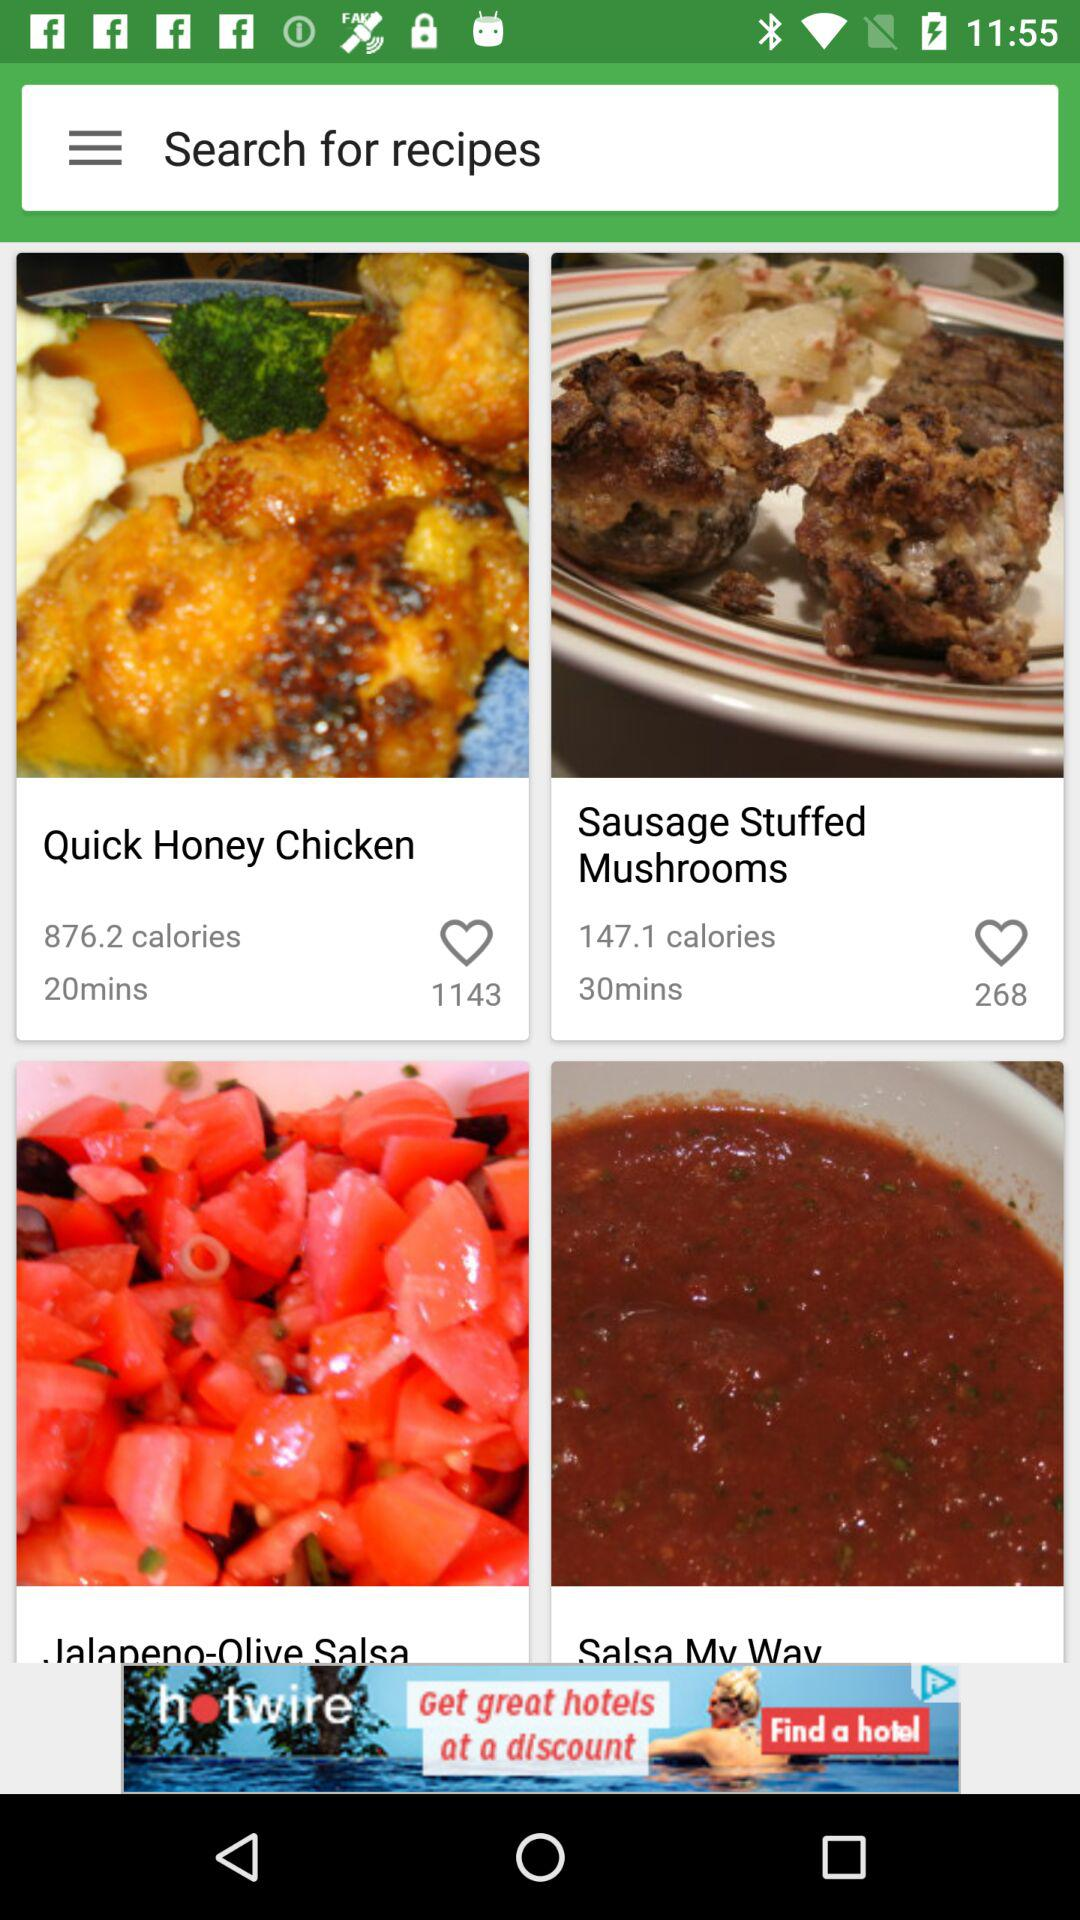How many ingredients are needed to make "Sausage Stuffed Mushrooms"?
When the provided information is insufficient, respond with <no answer>. <no answer> 